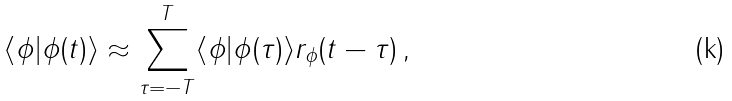Convert formula to latex. <formula><loc_0><loc_0><loc_500><loc_500>\langle \phi | \phi ( t ) \rangle \approx \sum _ { \tau = - T } ^ { T } \langle \phi | \phi ( \tau ) \rangle r _ { \phi } ( t - \tau ) \, ,</formula> 